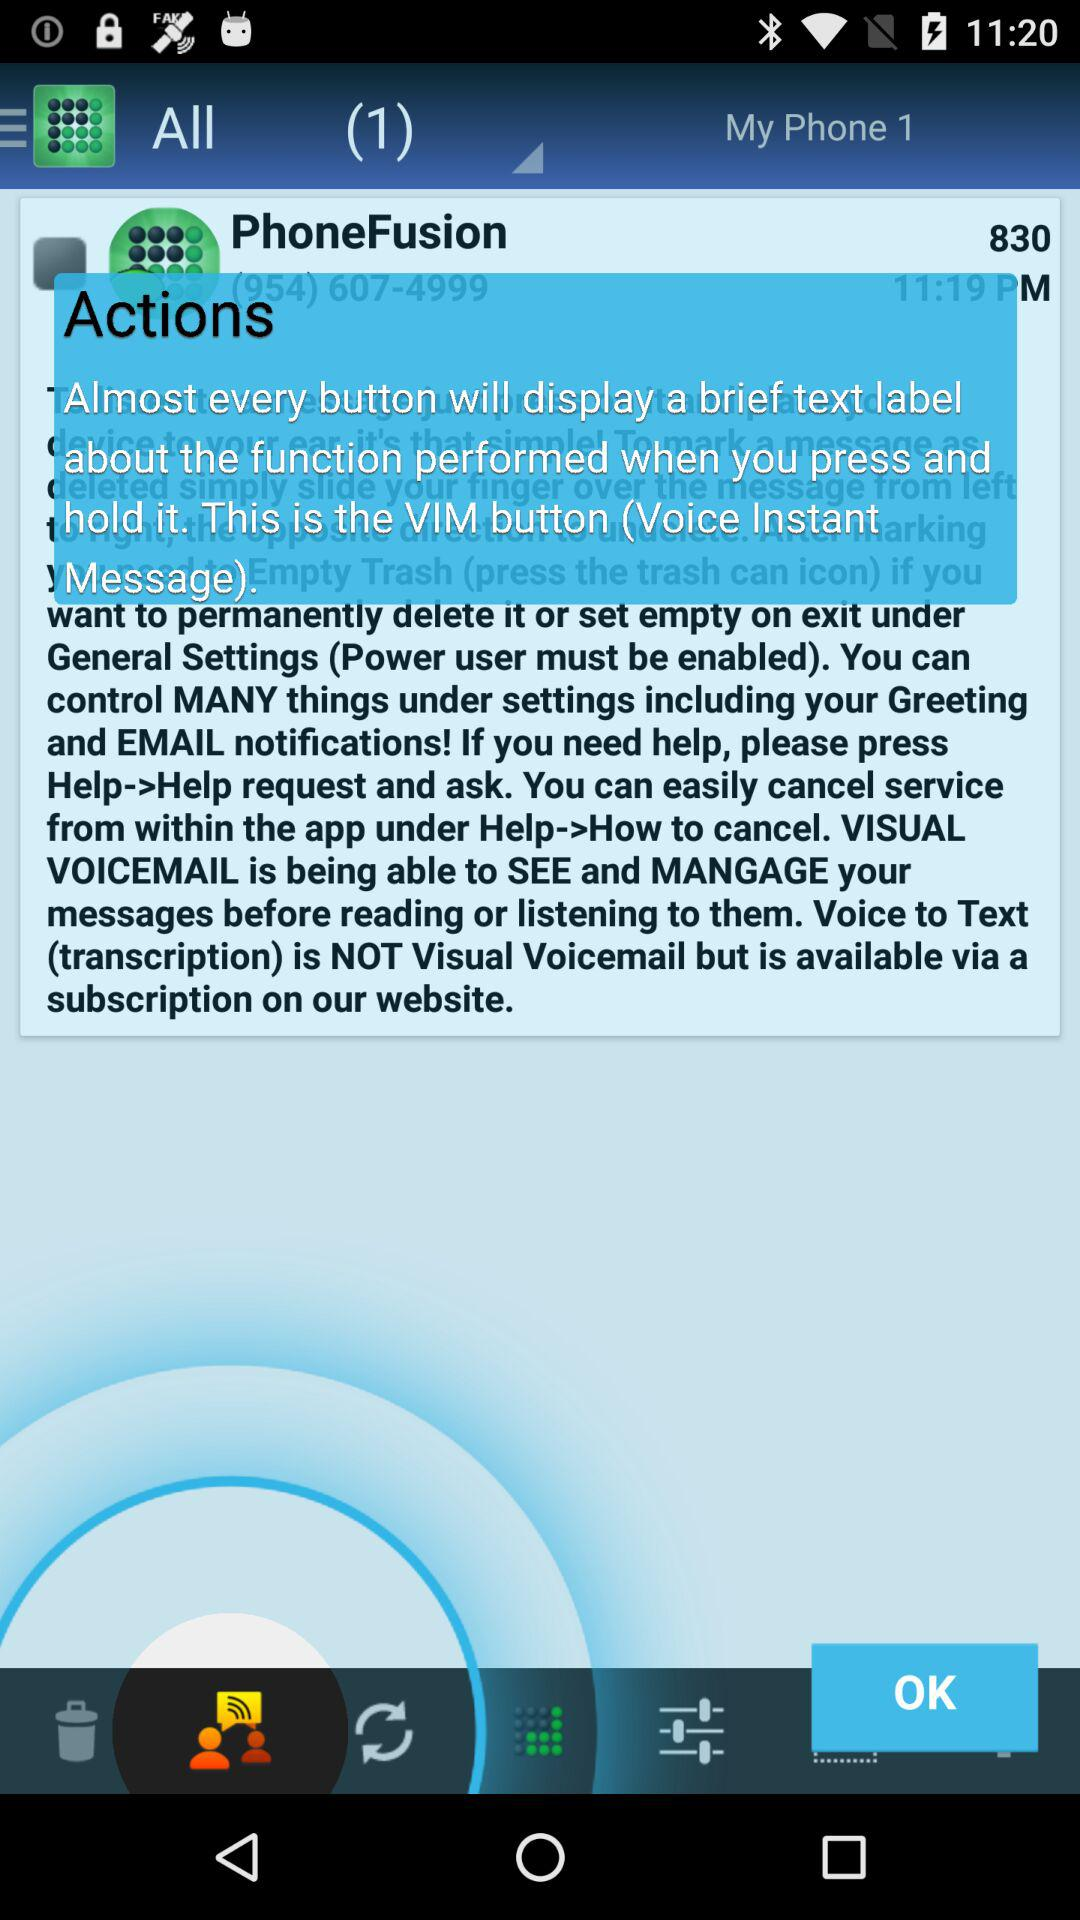What is the time of the message? The time of the message is 11:19 PM. 